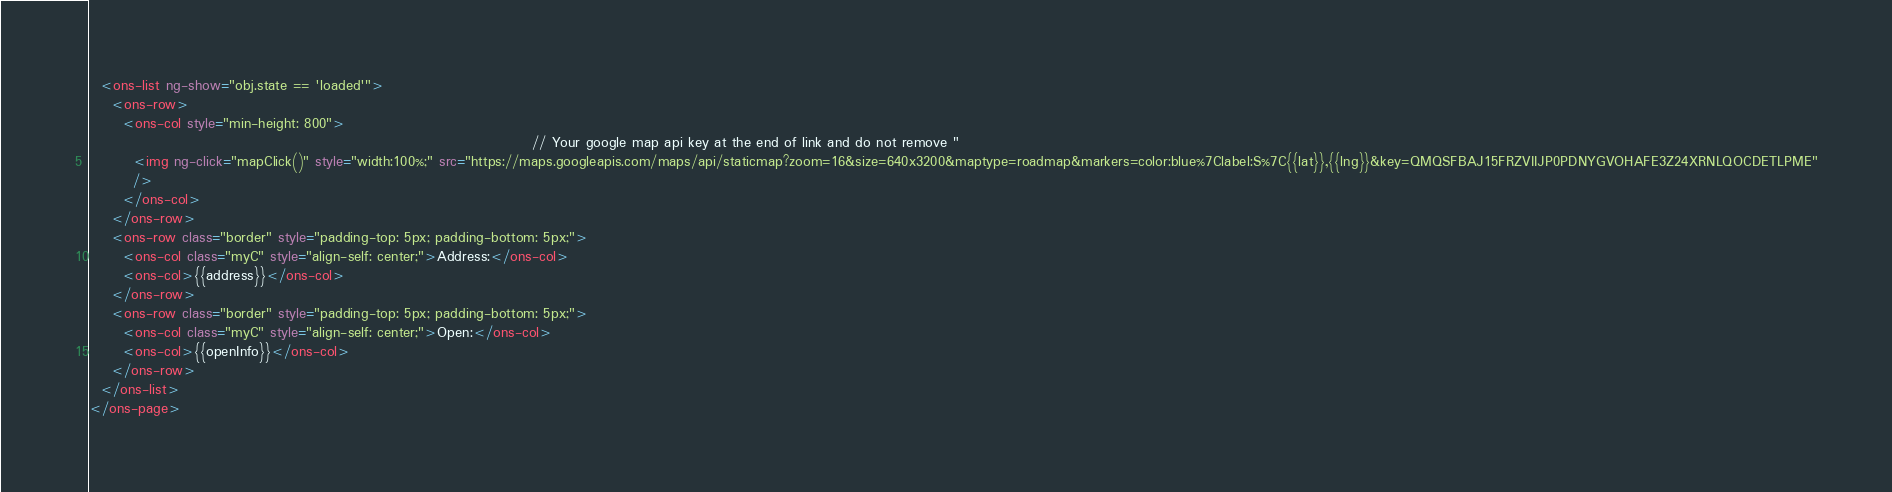<code> <loc_0><loc_0><loc_500><loc_500><_HTML_>  <ons-list ng-show="obj.state == 'loaded'">
    <ons-row>
      <ons-col style="min-height: 800">
                                                                                // Your google map api key at the end of link and do not remove "
        <img ng-click="mapClick()" style="width:100%;" src="https://maps.googleapis.com/maps/api/staticmap?zoom=16&size=640x3200&maptype=roadmap&markers=color:blue%7Clabel:S%7C{{lat}},{{lng}}&key=QMQSFBAJ15FRZVIIJP0PDNYGVOHAFE3Z24XRNLQOCDETLPME"
        />
      </ons-col>
    </ons-row>
    <ons-row class="border" style="padding-top: 5px; padding-bottom: 5px;">
      <ons-col class="myC" style="align-self: center;">Address:</ons-col>
      <ons-col>{{address}}</ons-col>
    </ons-row>
    <ons-row class="border" style="padding-top: 5px; padding-bottom: 5px;">
      <ons-col class="myC" style="align-self: center;">Open:</ons-col>
      <ons-col>{{openInfo}}</ons-col>
    </ons-row>
  </ons-list>
</ons-page>
</code> 